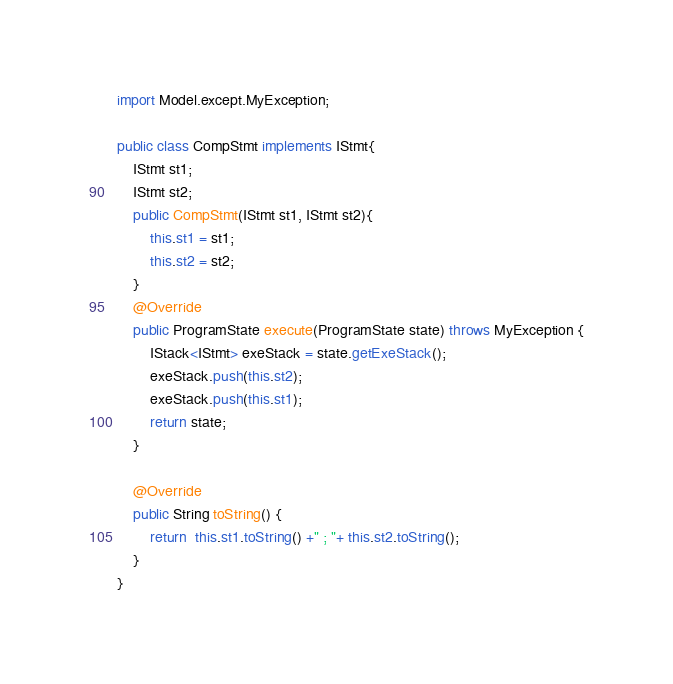<code> <loc_0><loc_0><loc_500><loc_500><_Java_>import Model.except.MyException;

public class CompStmt implements IStmt{
    IStmt st1;
    IStmt st2;
    public CompStmt(IStmt st1, IStmt st2){
        this.st1 = st1;
        this.st2 = st2;
    }
    @Override
    public ProgramState execute(ProgramState state) throws MyException {
        IStack<IStmt> exeStack = state.getExeStack();
        exeStack.push(this.st2);
        exeStack.push(this.st1);
        return state;
    }

    @Override
    public String toString() {
        return  this.st1.toString() +" ; "+ this.st2.toString();
    }
}
</code> 